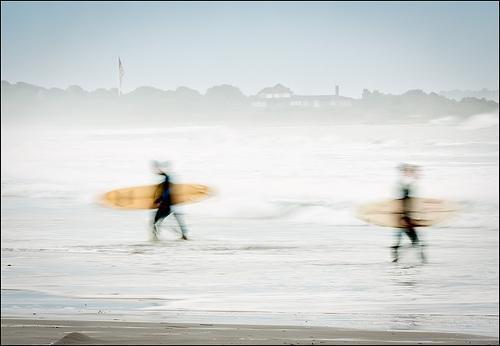How many people are there?
Give a very brief answer. 2. 